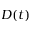<formula> <loc_0><loc_0><loc_500><loc_500>D ( t )</formula> 